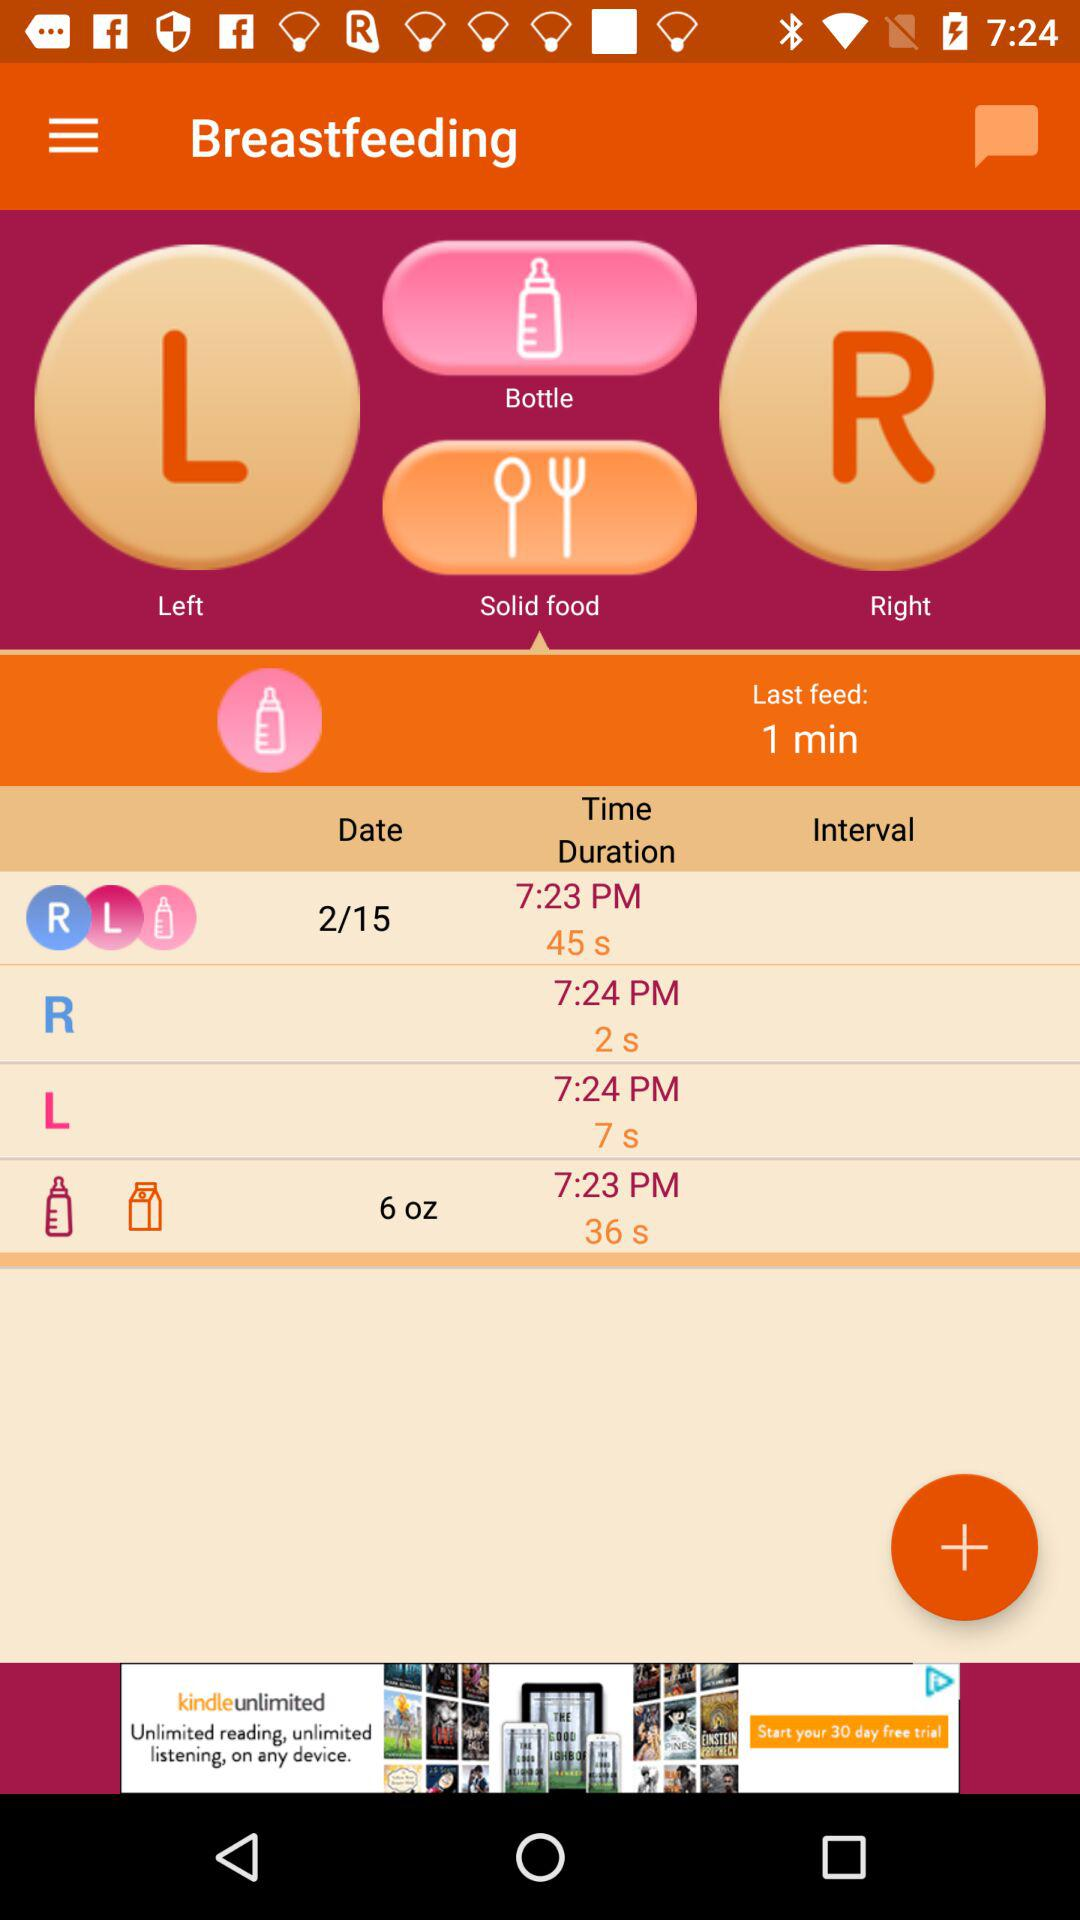What is the time duration of breastfeeding on 2/15 at 7:23 PM? The time duration of breastfeeding on 2/15 at 7:23 PM is 45 seconds. 